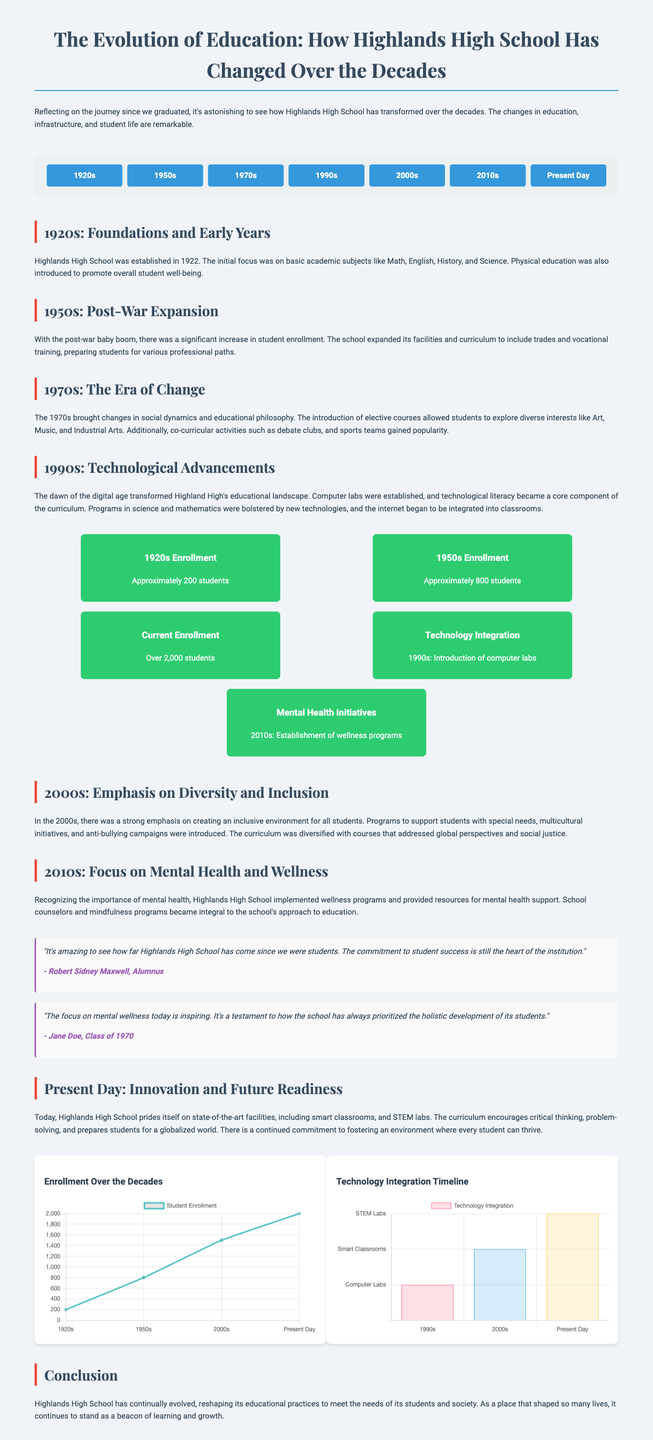What year was Highlands High School established? The document states that Highlands High School was established in 1922.
Answer: 1922 What was the primary focus of the curriculum in the 1920s? The curriculum in the 1920s centered around basic academic subjects like Math, English, History, and Science.
Answer: Basic academic subjects How many students were enrolled in the 1950s? The document indicates that there were approximately 800 students enrolled in the 1950s.
Answer: Approximately 800 students What major initiative was introduced in the 2010s? The 2010s saw the establishment of wellness programs focusing on mental health.
Answer: Wellness programs How did student enrollment change from the 1920s to the present day? Enrollment saw an increase from approximately 200 students in the 1920s to over 2,000 students currently.
Answer: Increased to over 2,000 students What technology was introduced in the 1990s? The document mentions that computer labs were established as part of technology integration in the 1990s.
Answer: Computer labs Which decade emphasized diversity and inclusion? The 2000s focused on creating an inclusive environment for all students.
Answer: 2000s What is the purpose of the quotes section in the document? The quotes section includes reflections from alumni highlighting the school's evolution and commitment to student success.
Answer: Reflection from alumni What is shown in the graphs section of the document? The graphs section displays enrollment trends over the decades and the timeline of technology integration.
Answer: Enrollment trends and technology integration timeline 